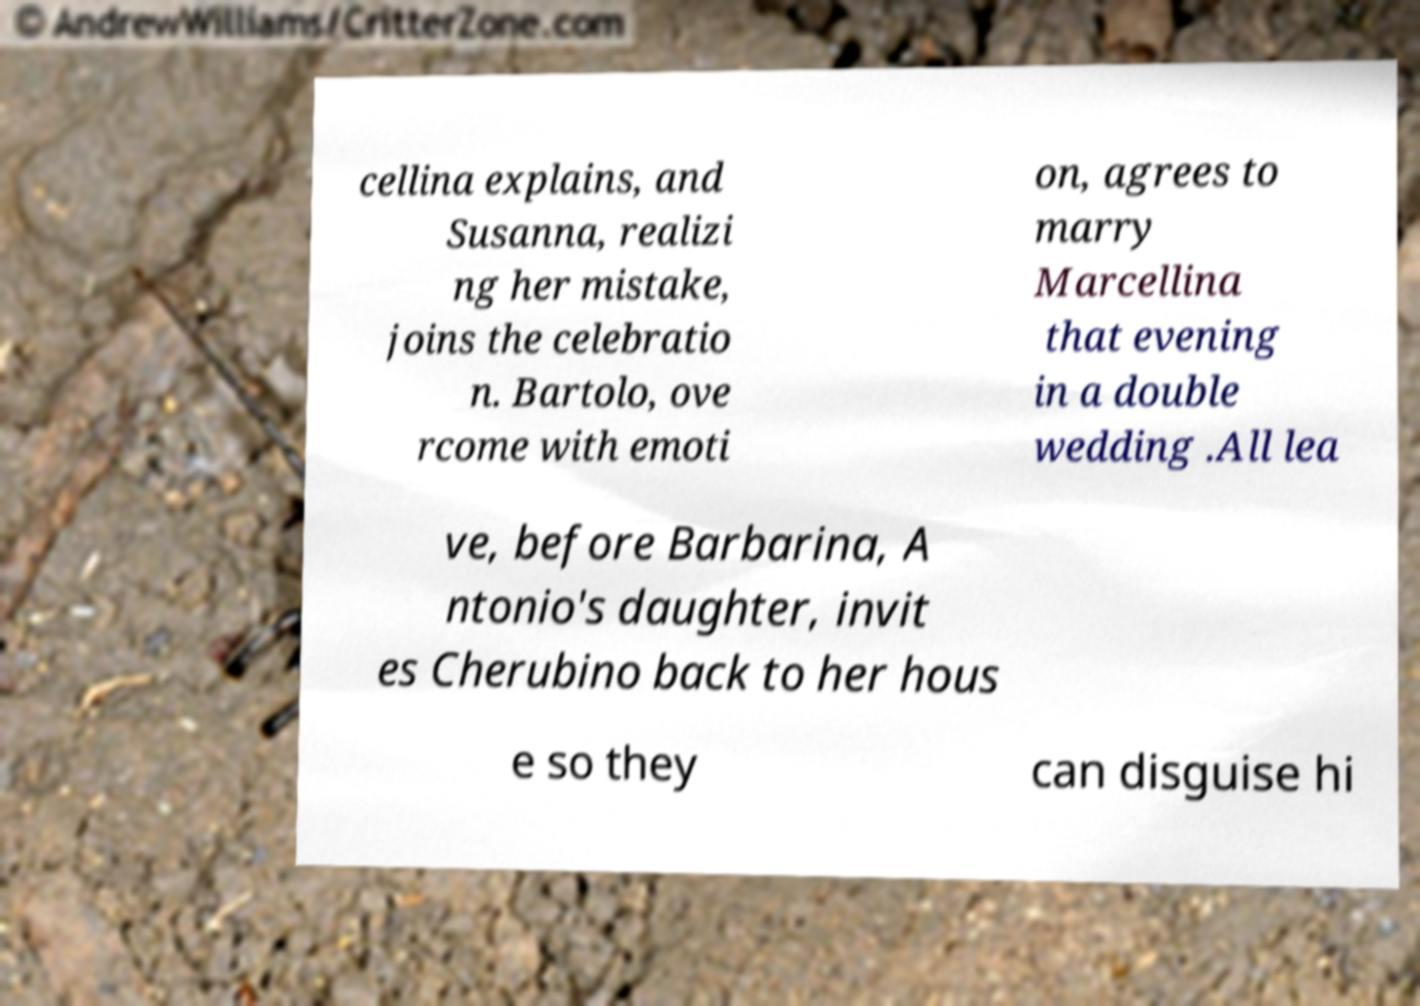Please read and relay the text visible in this image. What does it say? cellina explains, and Susanna, realizi ng her mistake, joins the celebratio n. Bartolo, ove rcome with emoti on, agrees to marry Marcellina that evening in a double wedding .All lea ve, before Barbarina, A ntonio's daughter, invit es Cherubino back to her hous e so they can disguise hi 